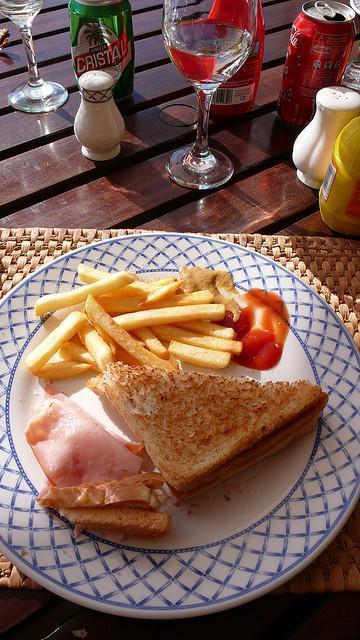Where was this sandwich likely cooked?
Indicate the correct response and explain using: 'Answer: answer
Rationale: rationale.'
Options: Grill, oven, microwave, fire. Answer: grill.
Rationale: This sandwich was most likely grilled, like a grilled cheese. 